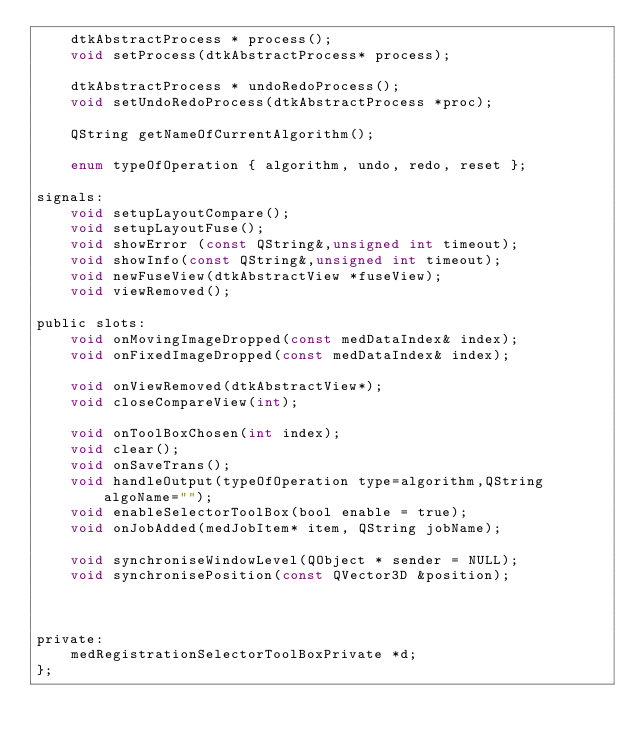<code> <loc_0><loc_0><loc_500><loc_500><_C_>    dtkAbstractProcess * process();
    void setProcess(dtkAbstractProcess* process);

    dtkAbstractProcess * undoRedoProcess();
    void setUndoRedoProcess(dtkAbstractProcess *proc);

    QString getNameOfCurrentAlgorithm();

    enum typeOfOperation { algorithm, undo, redo, reset };

signals:
    void setupLayoutCompare();
    void setupLayoutFuse();
    void showError (const QString&,unsigned int timeout);
    void showInfo(const QString&,unsigned int timeout);
    void newFuseView(dtkAbstractView *fuseView);
    void viewRemoved();

public slots:
    void onMovingImageDropped(const medDataIndex& index);
    void onFixedImageDropped(const medDataIndex& index);

    void onViewRemoved(dtkAbstractView*);
    void closeCompareView(int);

    void onToolBoxChosen(int index);
    void clear();
    void onSaveTrans();
    void handleOutput(typeOfOperation type=algorithm,QString algoName="");
    void enableSelectorToolBox(bool enable = true);
    void onJobAdded(medJobItem* item, QString jobName);
    
    void synchroniseWindowLevel(QObject * sender = NULL);
    void synchronisePosition(const QVector3D &position);

    

private:
    medRegistrationSelectorToolBoxPrivate *d;
};


</code> 